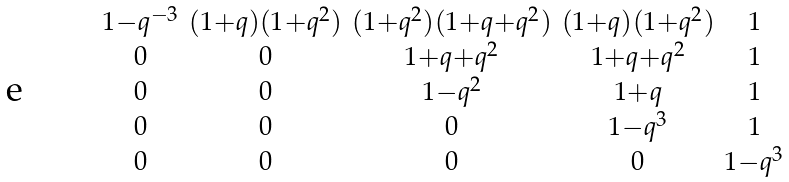Convert formula to latex. <formula><loc_0><loc_0><loc_500><loc_500>\begin{smallmatrix} 1 - q ^ { - 3 } & ( 1 + q ) ( 1 + q ^ { 2 } ) & ( 1 + q ^ { 2 } ) ( 1 + q + q ^ { 2 } ) & ( 1 + q ) ( 1 + q ^ { 2 } ) & 1 \\ 0 & 0 & 1 + q + q ^ { 2 } & 1 + q + q ^ { 2 } & 1 \\ 0 & 0 & 1 - q ^ { 2 } & 1 + q & 1 \\ 0 & 0 & 0 & 1 - q ^ { 3 } & 1 \\ 0 & 0 & 0 & 0 & 1 - q ^ { 3 } \\ \end{smallmatrix}</formula> 